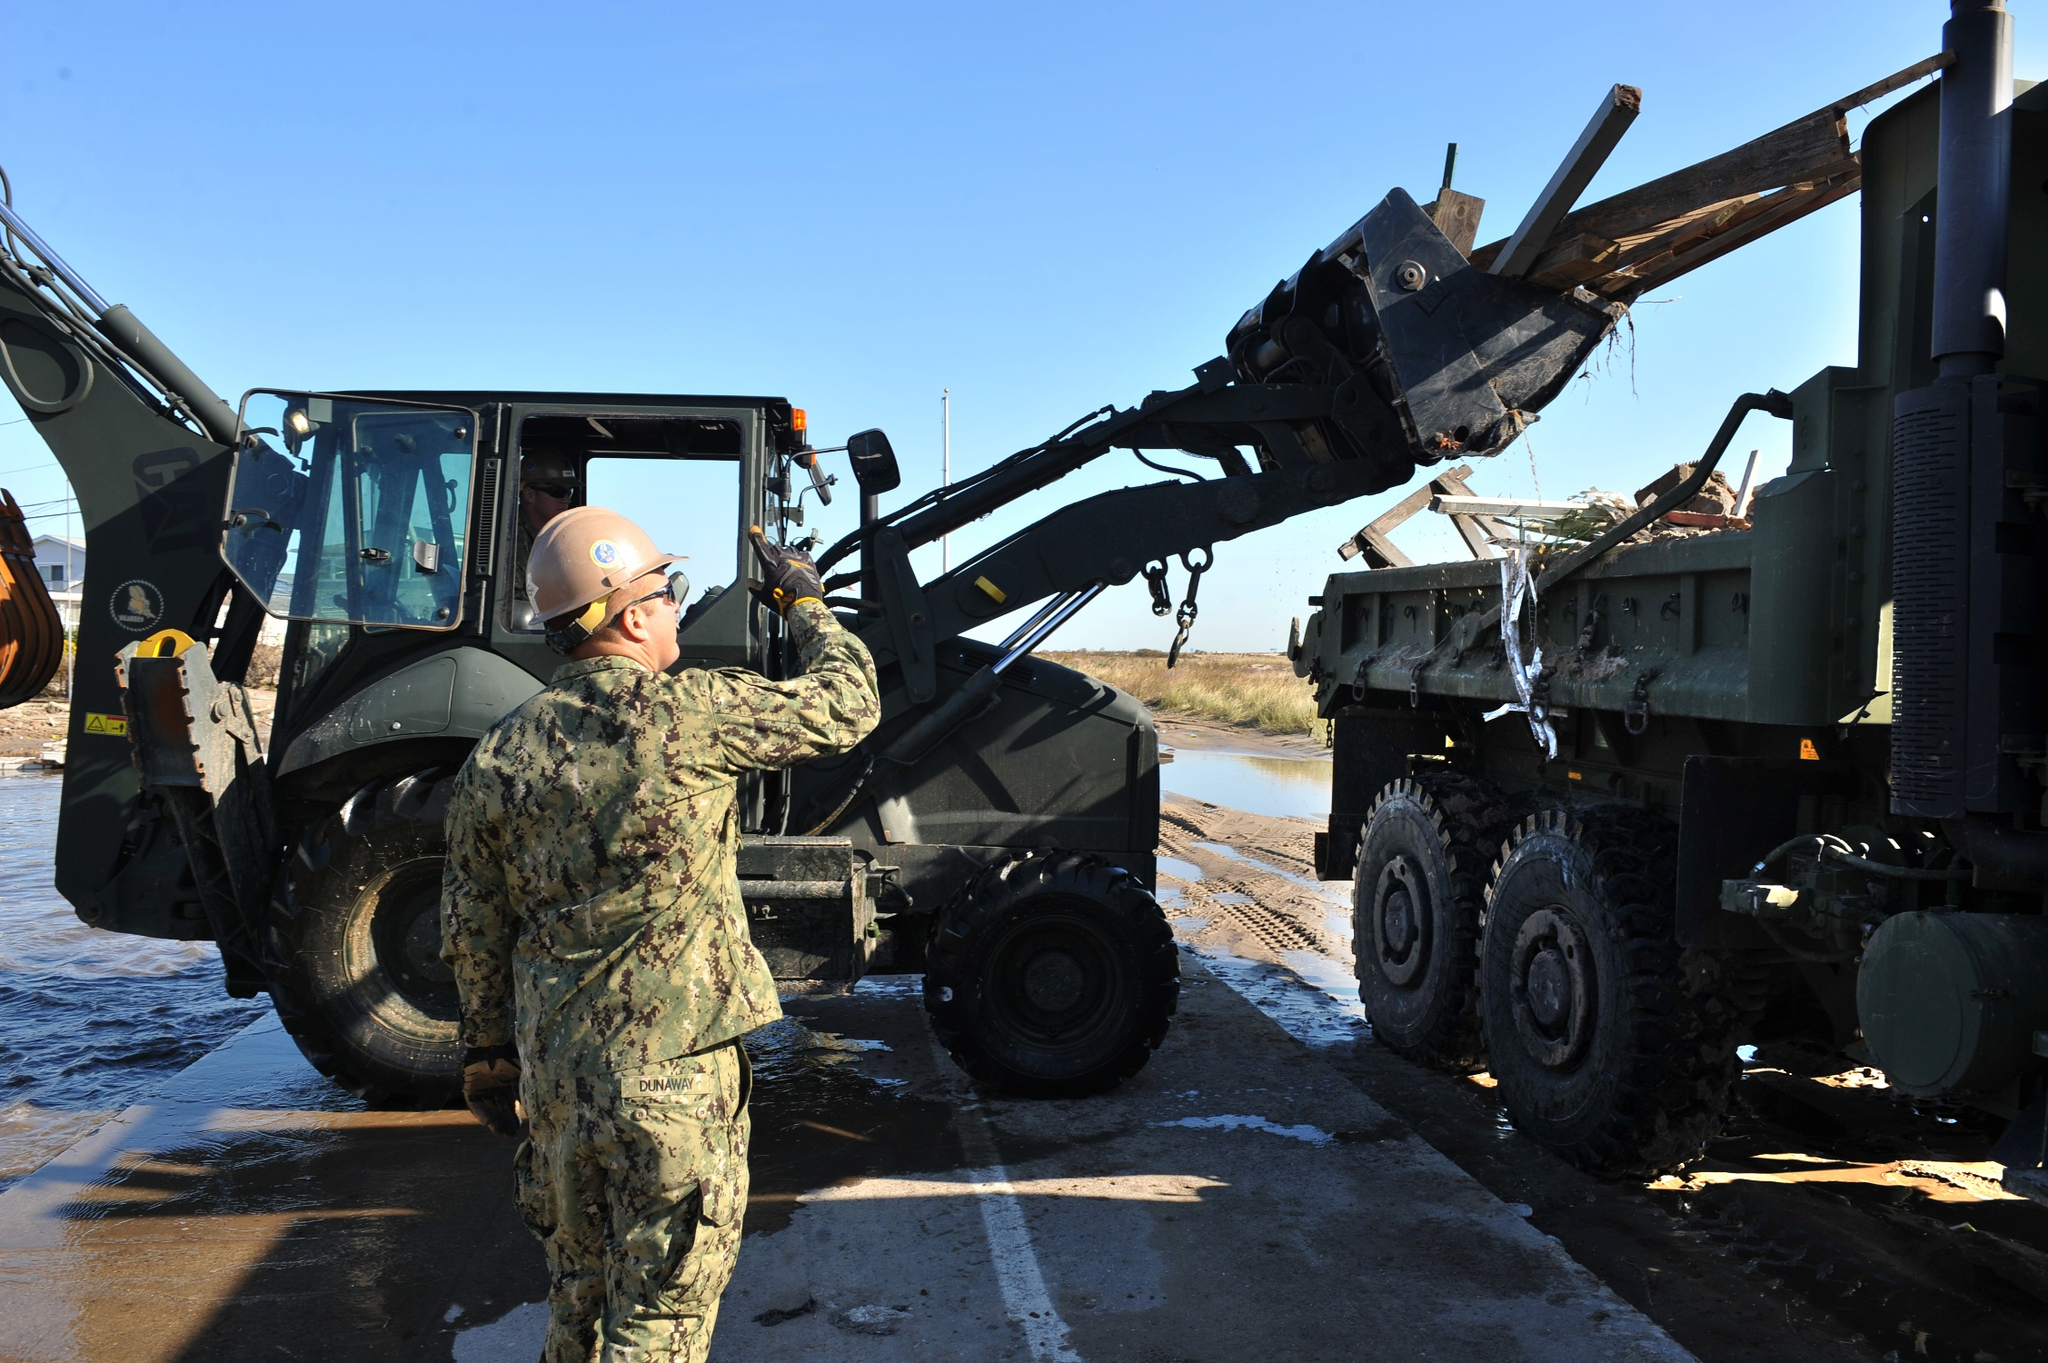What's happening in the scene? In the heart of a bustling construction site, under the clear blue sky, a worker dressed in a military uniform and a protective hard hat is operating a forklift. The forklift, in its powerful grip, is lifting a large wooden beam from a military truck. The truck, filled with similar beams, is parked on a dirt road adjacent to a calm body of water. The sun, high in the sky, casts a bright light over the scene, highlighting the meticulous work being done. The worker's focus is unwavering, a testament to the precision and dedication required in such an environment. Despite the surrounding activity, the water remains undisturbed, providing a stark contrast to the industrious scene on the shore. This image captures a moment of diligent work in progress, set against a backdrop of natural tranquility. 